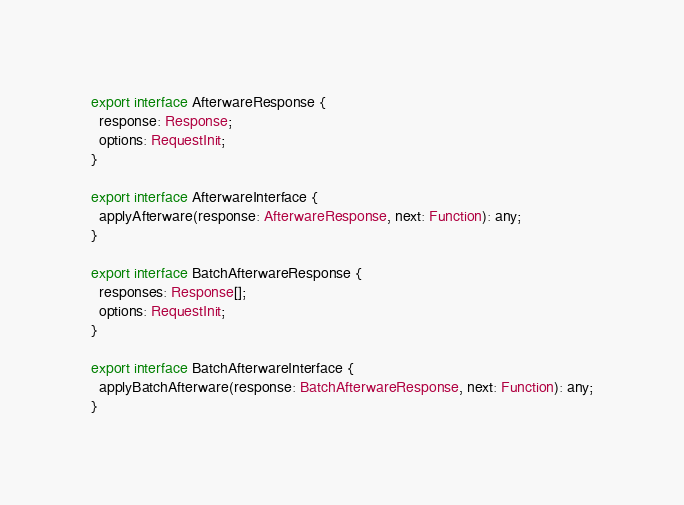Convert code to text. <code><loc_0><loc_0><loc_500><loc_500><_TypeScript_>export interface AfterwareResponse {
  response: Response;
  options: RequestInit;
}

export interface AfterwareInterface {
  applyAfterware(response: AfterwareResponse, next: Function): any;
}

export interface BatchAfterwareResponse {
  responses: Response[];
  options: RequestInit;
}

export interface BatchAfterwareInterface {
  applyBatchAfterware(response: BatchAfterwareResponse, next: Function): any;
}
</code> 